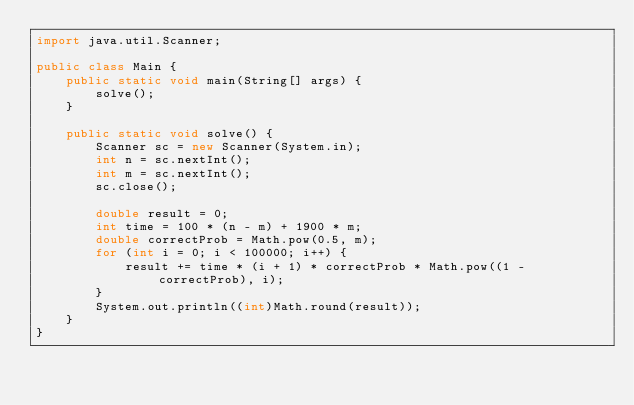<code> <loc_0><loc_0><loc_500><loc_500><_Java_>import java.util.Scanner;

public class Main {
	public static void main(String[] args) {
		solve();
	}

	public static void solve() {
		Scanner sc = new Scanner(System.in);
		int n = sc.nextInt();
		int m = sc.nextInt();
		sc.close();

		double result = 0;
		int time = 100 * (n - m) + 1900 * m;
		double correctProb = Math.pow(0.5, m);
		for (int i = 0; i < 100000; i++) {
			result += time * (i + 1) * correctProb * Math.pow((1 - correctProb), i);
		}
		System.out.println((int)Math.round(result));
	}
}
</code> 